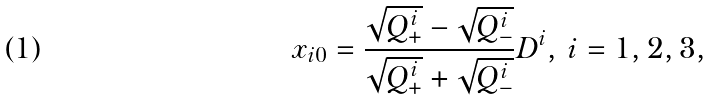Convert formula to latex. <formula><loc_0><loc_0><loc_500><loc_500>x _ { i 0 } = \frac { \sqrt { Q ^ { i } _ { + } } - \sqrt { Q ^ { i } _ { - } } } { \sqrt { Q ^ { i } _ { + } } + \sqrt { Q ^ { i } _ { - } } } D ^ { i } , \, i = 1 , 2 , 3 ,</formula> 